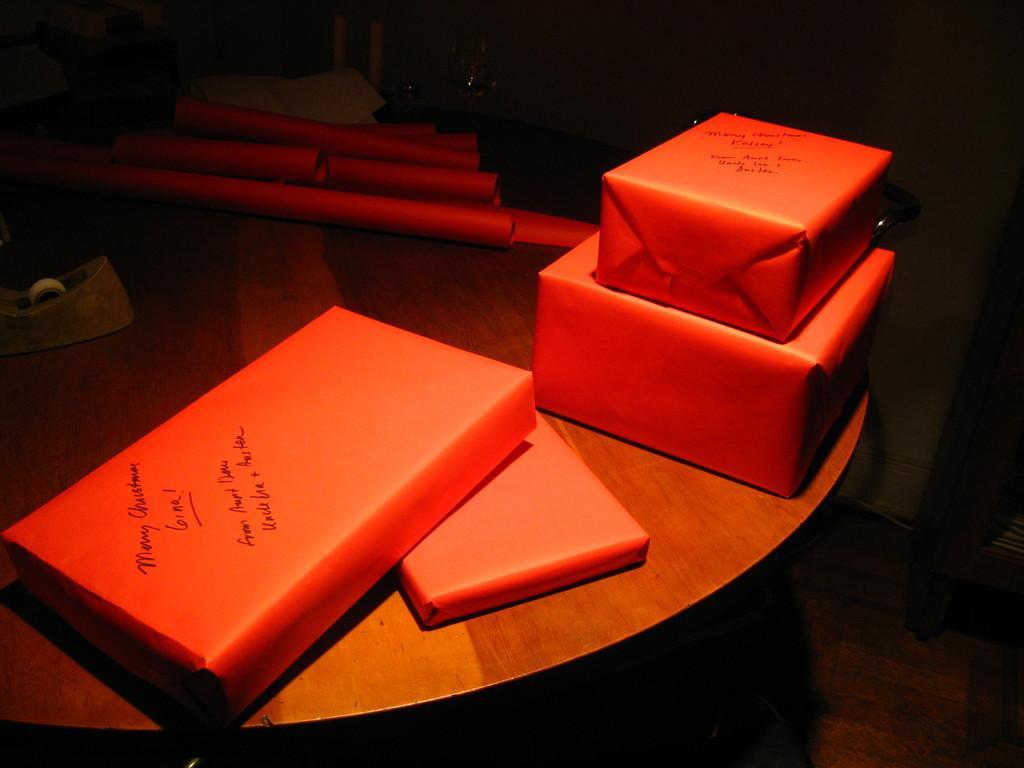How would you summarize this image in a sentence or two? in this image there is one table at left side of this image and there is one object kept on this table is at left of this image and there are some objects kept on to this table as we can see in middle of this image, and there is some text written on the object which is at bottom left side of this image. 